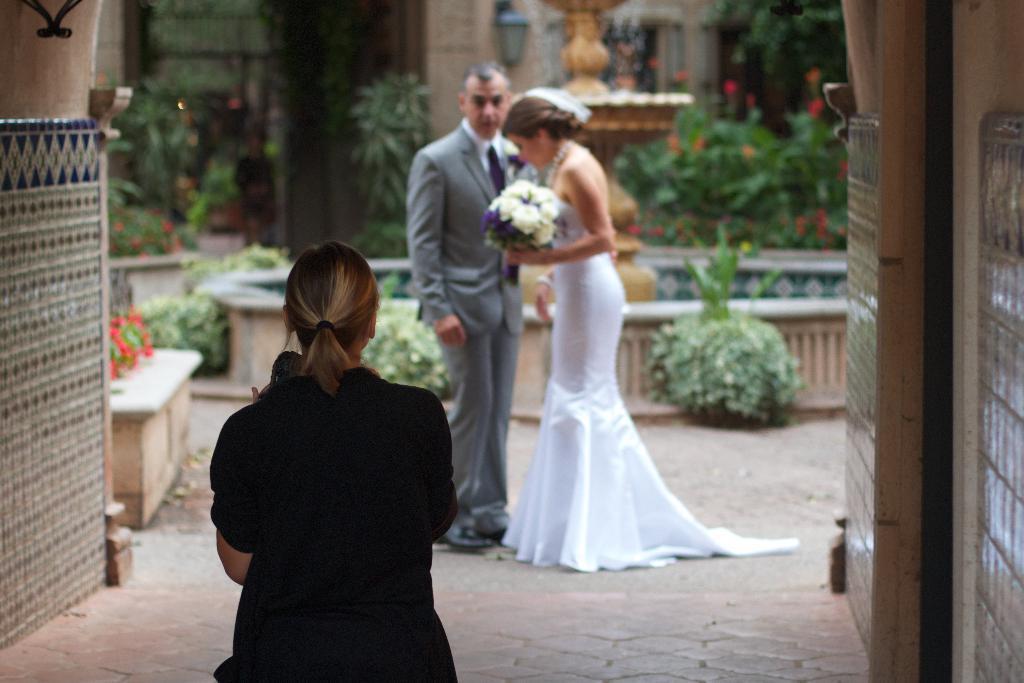In one or two sentences, can you explain what this image depicts? In this image we can see a lady. On the sides there are walls. In the back there's a lady holding a bouquet. Also there is a man. Also there is a bench. There are plants. And there is a fountain. In the background it is blur. 